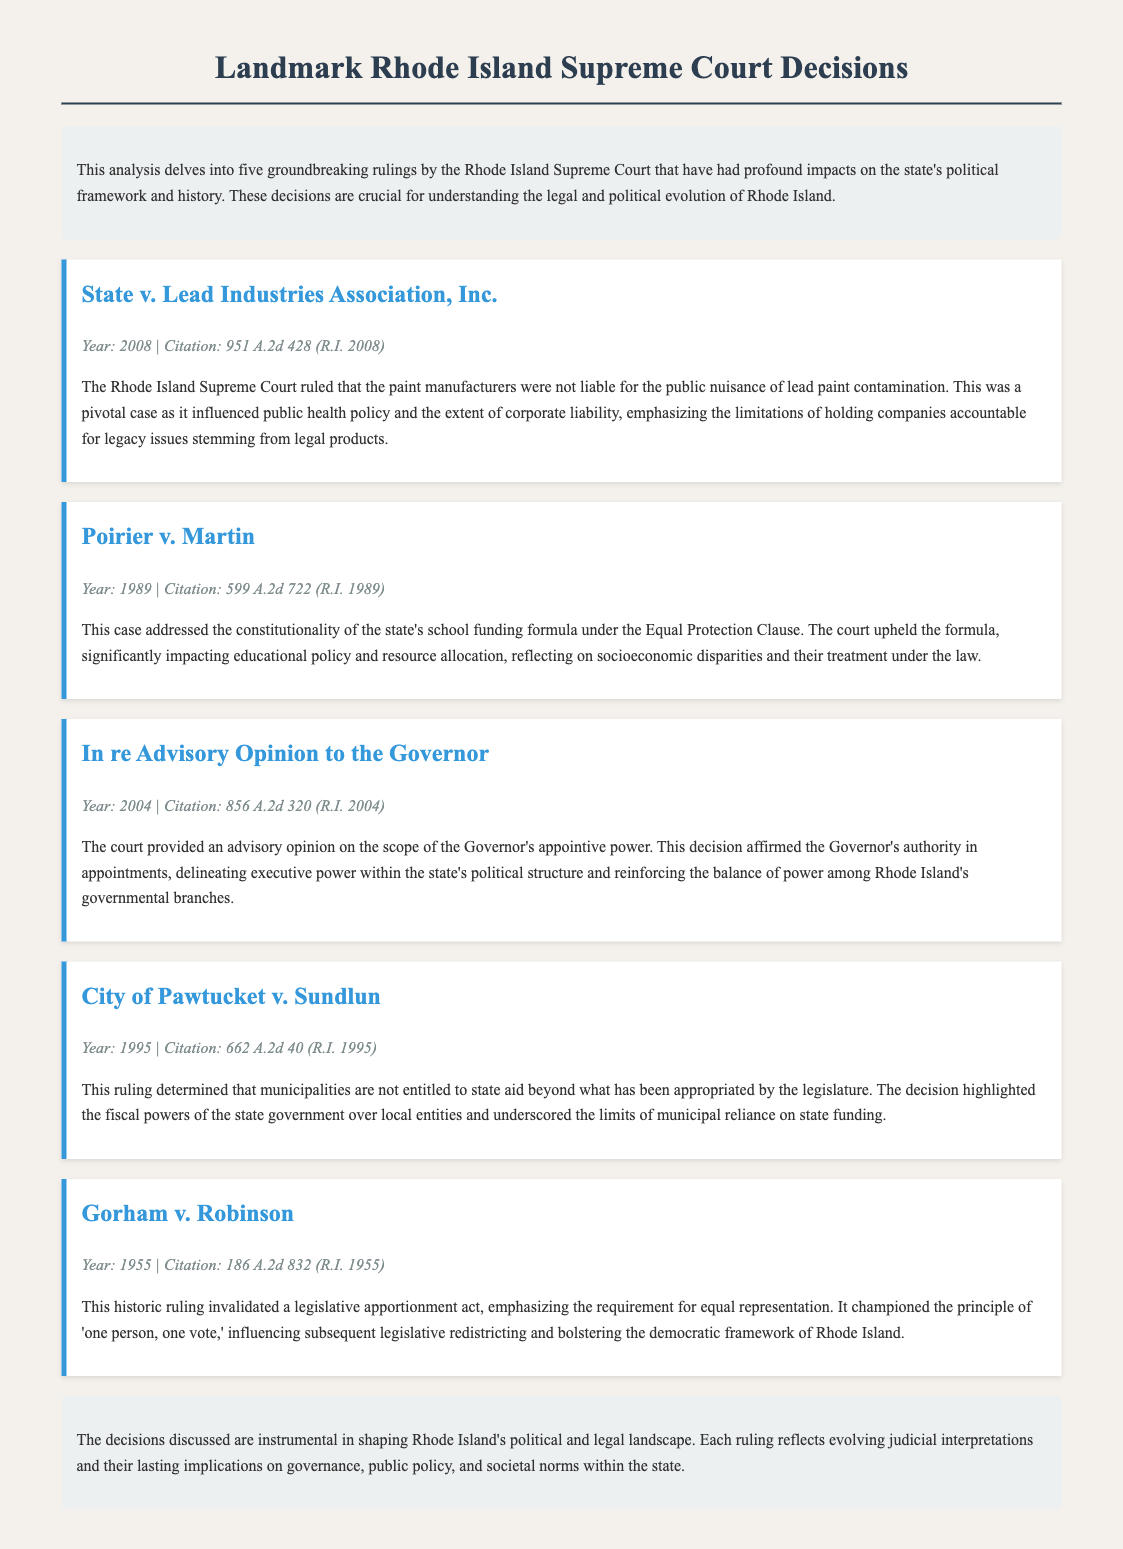What year was the case State v. Lead Industries Association decided? The document states that State v. Lead Industries Association was decided in 2008.
Answer: 2008 What is the citation for the case Poirier v. Martin? The citation for Poirier v. Martin is found in the document as 599 A.2d 722 (R.I. 1989).
Answer: 599 A.2d 722 (R.I. 1989) Which case addressed the constitutionality of the state's school funding formula? The document mentions that Poirier v. Martin addressed the constitutionality of the state's school funding formula.
Answer: Poirier v. Martin What principle was championed by the ruling in Gorham v. Robinson? The ruling in Gorham v. Robinson emphasized the principle of 'one person, one vote.'
Answer: 'one person, one vote' What was determined about municipalities in City of Pawtucket v. Sundlun? The document states that municipalities are not entitled to state aid beyond what has been appropriated by the legislature.
Answer: Not entitled to state aid beyond appropriated amount What type of opinion did the court provide in In re Advisory Opinion to the Governor? The court provided an advisory opinion regarding the scope of the Governor's appointive power.
Answer: Advisory opinion What year was Gorham v. Robinson decided? The document notes that Gorham v. Robinson was decided in 1955.
Answer: 1955 How many key rulings are analyzed in the document? The document mentions that five key rulings are analyzed.
Answer: Five What was a significant impact of the ruling in State v. Lead Industries Association? The ruling influenced public health policy and corporate liability.
Answer: Public health policy and corporate liability 